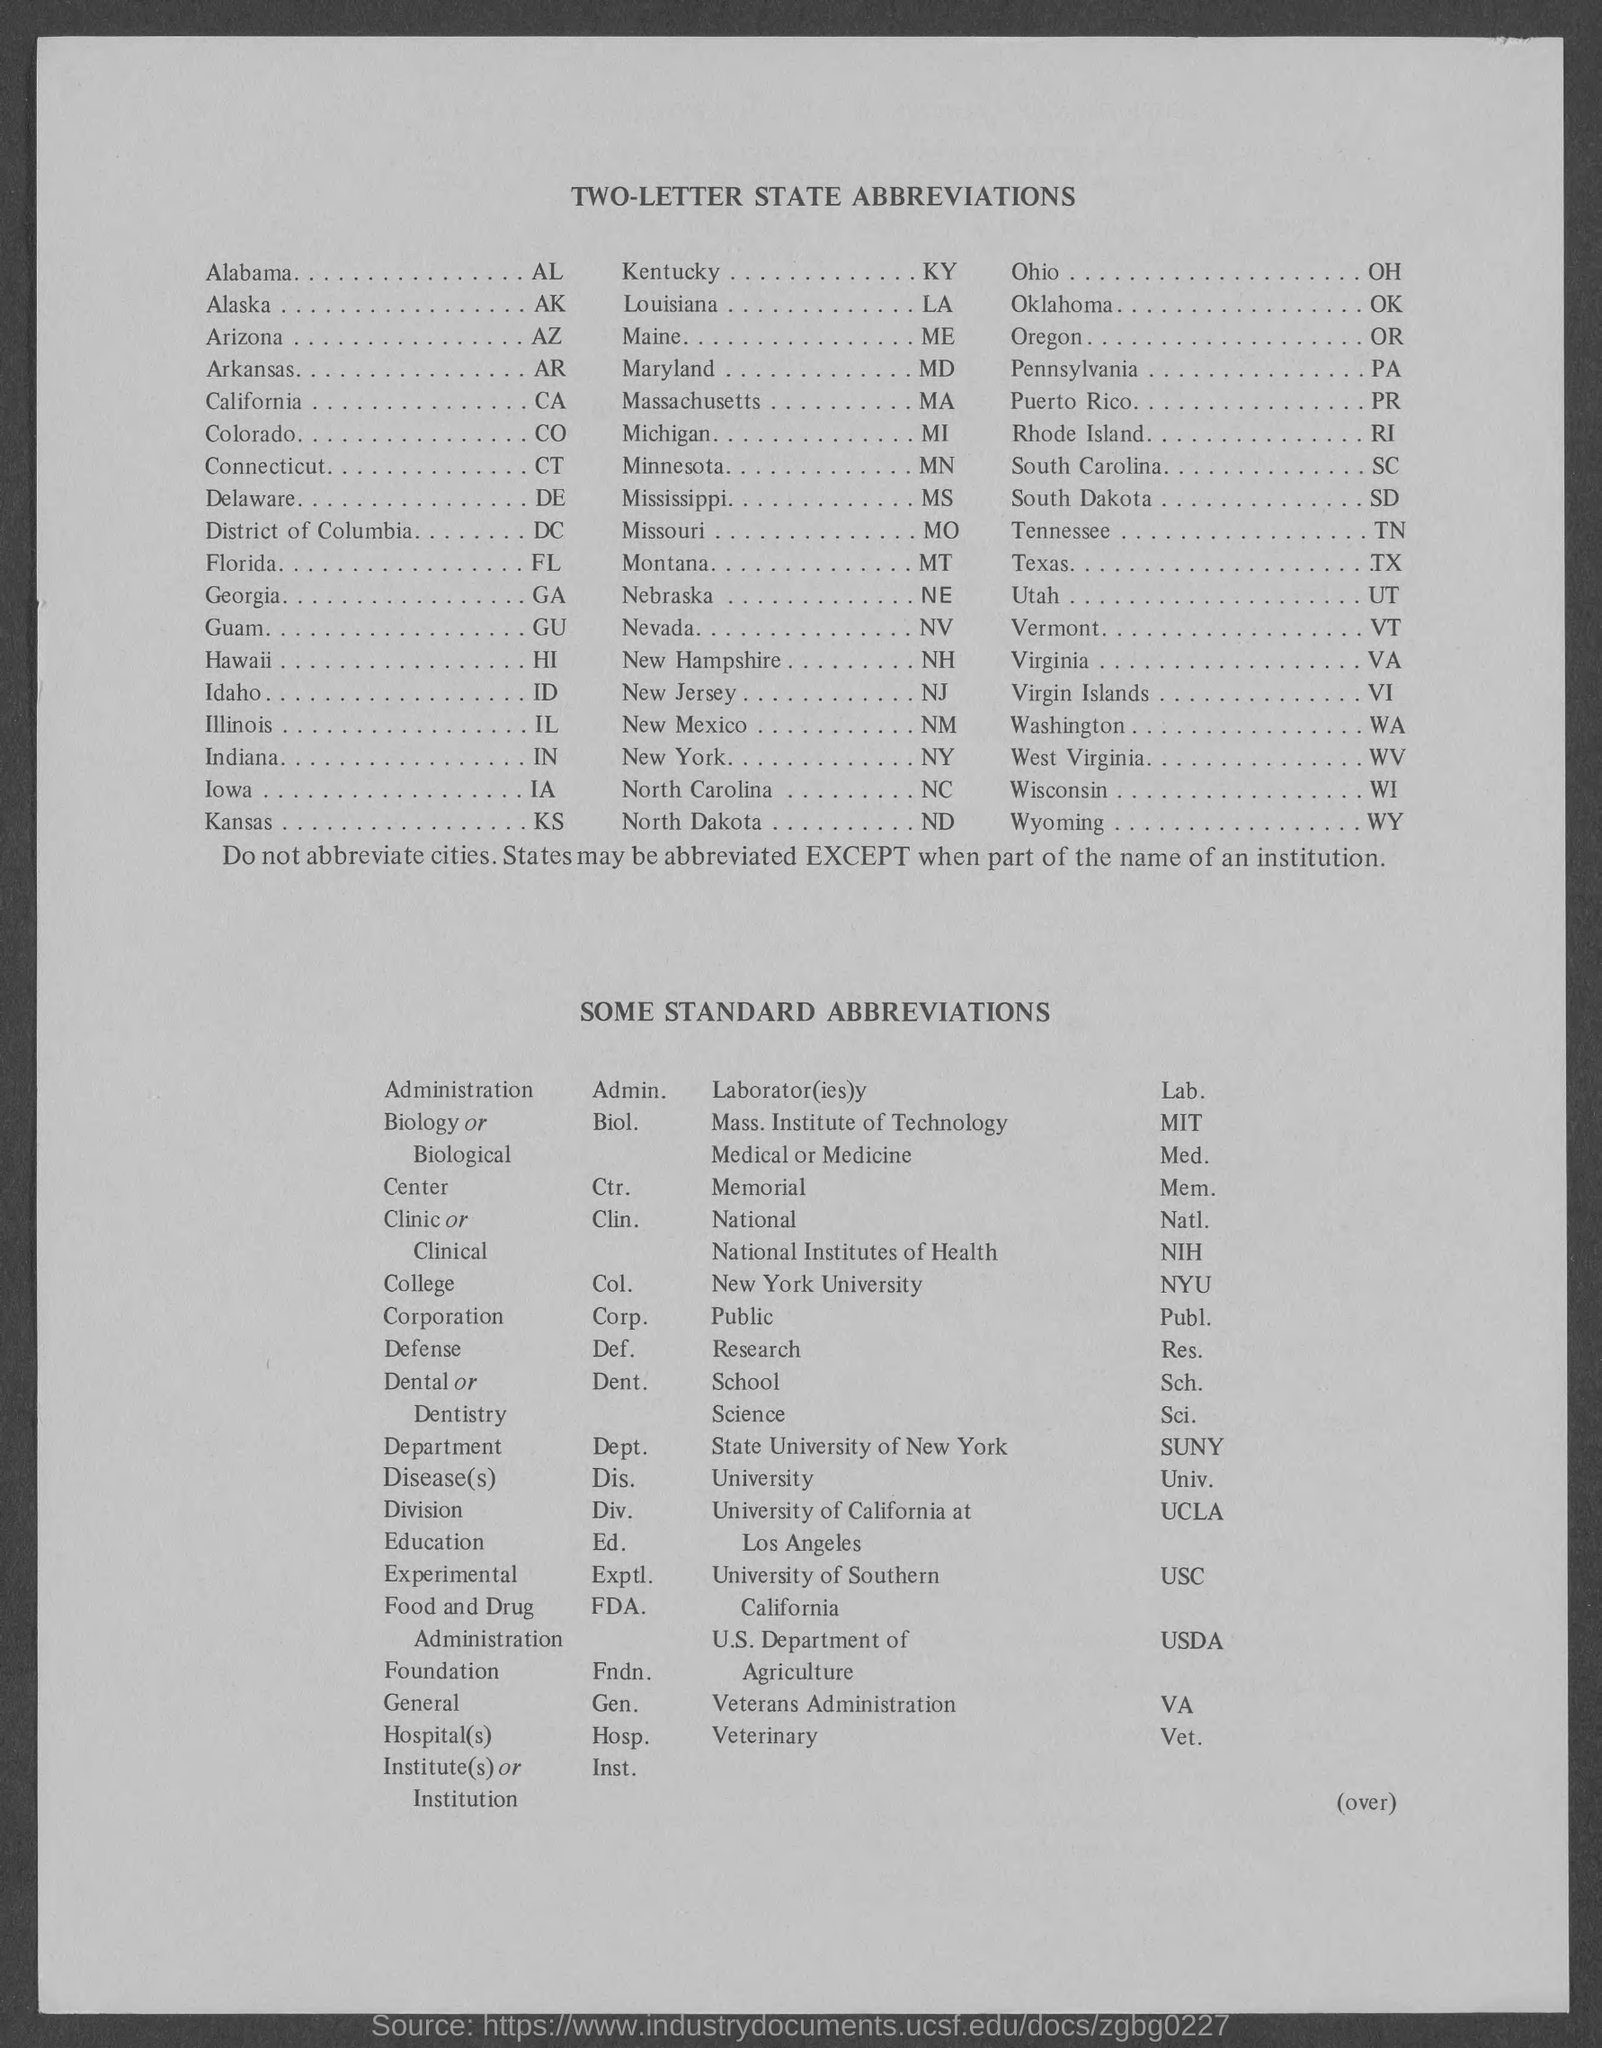What is the abbreviation for Alaska? The abbreviation for Alaska is 'AK'. Alaska is the largest state in the United States by area, and it's known for its diverse terrain of open spaces, mountains, forests, and abundant wildlife, with a relatively sparse population. 'AK' is used in postal addresses and other contexts where a two-letter state code is needed. 